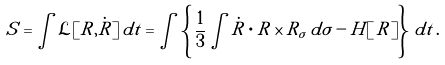Convert formula to latex. <formula><loc_0><loc_0><loc_500><loc_500>S = \int \mathcal { L } [ R , \dot { R } ] \, d t = \int \left \{ \, \frac { 1 } { 3 } \int \dot { R } \cdot R \times R _ { \sigma } \, d \sigma - H [ \, R ] \right \} \, d t \, .</formula> 